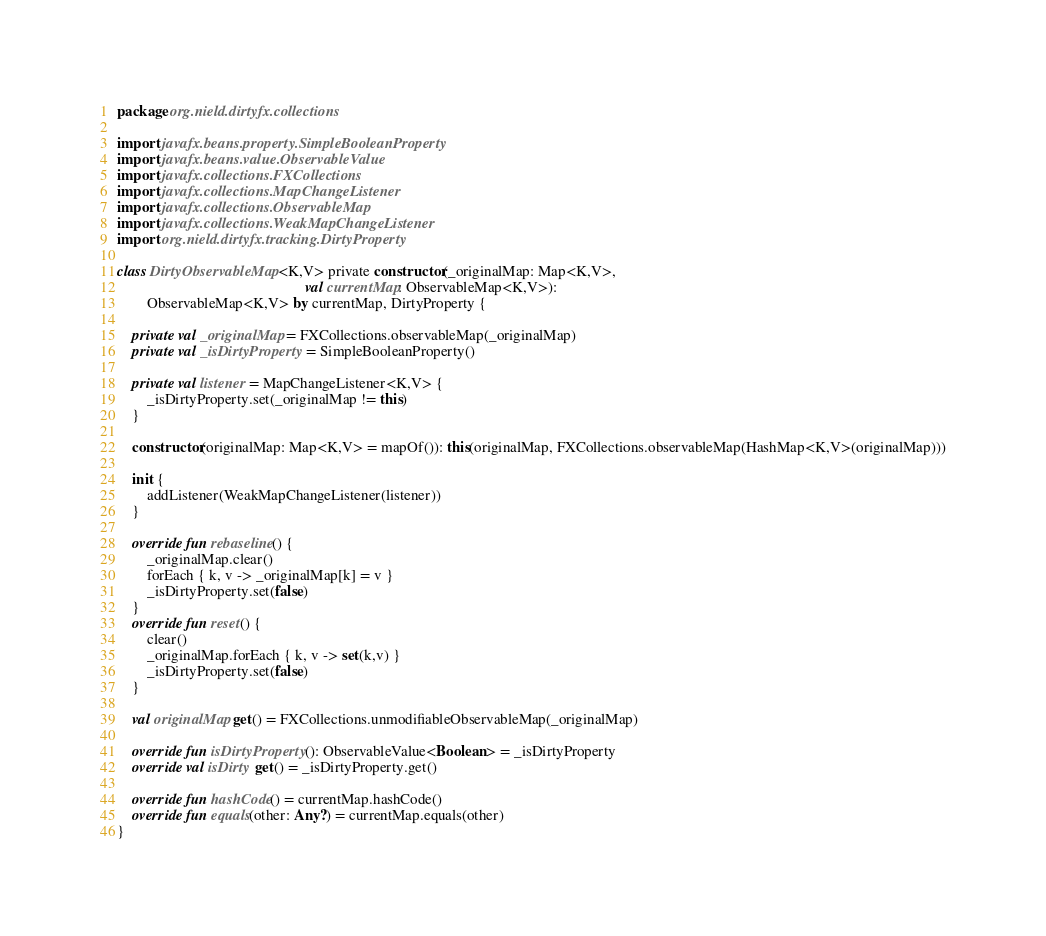<code> <loc_0><loc_0><loc_500><loc_500><_Kotlin_>package org.nield.dirtyfx.collections

import javafx.beans.property.SimpleBooleanProperty
import javafx.beans.value.ObservableValue
import javafx.collections.FXCollections
import javafx.collections.MapChangeListener
import javafx.collections.ObservableMap
import javafx.collections.WeakMapChangeListener
import org.nield.dirtyfx.tracking.DirtyProperty

class DirtyObservableMap<K,V> private constructor(_originalMap: Map<K,V>,
                                                  val currentMap: ObservableMap<K,V>):
        ObservableMap<K,V> by currentMap, DirtyProperty {

    private val _originalMap = FXCollections.observableMap(_originalMap)
    private val _isDirtyProperty = SimpleBooleanProperty()

    private val listener = MapChangeListener<K,V> {
        _isDirtyProperty.set(_originalMap != this)
    }

    constructor(originalMap: Map<K,V> = mapOf()): this(originalMap, FXCollections.observableMap(HashMap<K,V>(originalMap)))

    init {
        addListener(WeakMapChangeListener(listener))
    }

    override fun rebaseline() {
        _originalMap.clear()
        forEach { k, v -> _originalMap[k] = v }
        _isDirtyProperty.set(false)
    }
    override fun reset() {
        clear()
        _originalMap.forEach { k, v -> set(k,v) }
        _isDirtyProperty.set(false)
    }

    val originalMap get() = FXCollections.unmodifiableObservableMap(_originalMap)

    override fun isDirtyProperty(): ObservableValue<Boolean> = _isDirtyProperty
    override val isDirty get() = _isDirtyProperty.get()

    override fun hashCode() = currentMap.hashCode()
    override fun equals(other: Any?) = currentMap.equals(other)
}
</code> 